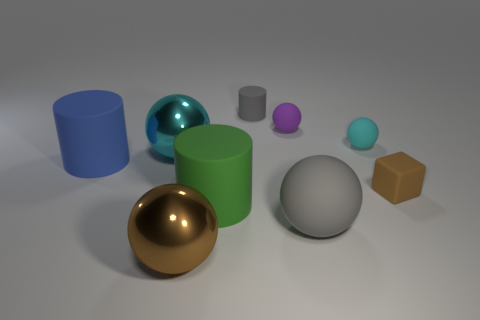Subtract 2 balls. How many balls are left? 3 Subtract all brown balls. How many balls are left? 4 Subtract all gray spheres. How many spheres are left? 4 Subtract all cyan balls. Subtract all purple cubes. How many balls are left? 3 Add 1 red spheres. How many objects exist? 10 Subtract all cylinders. How many objects are left? 6 Subtract all large cyan metal objects. Subtract all brown shiny spheres. How many objects are left? 7 Add 2 large blue rubber cylinders. How many large blue rubber cylinders are left? 3 Add 3 green things. How many green things exist? 4 Subtract 0 blue blocks. How many objects are left? 9 